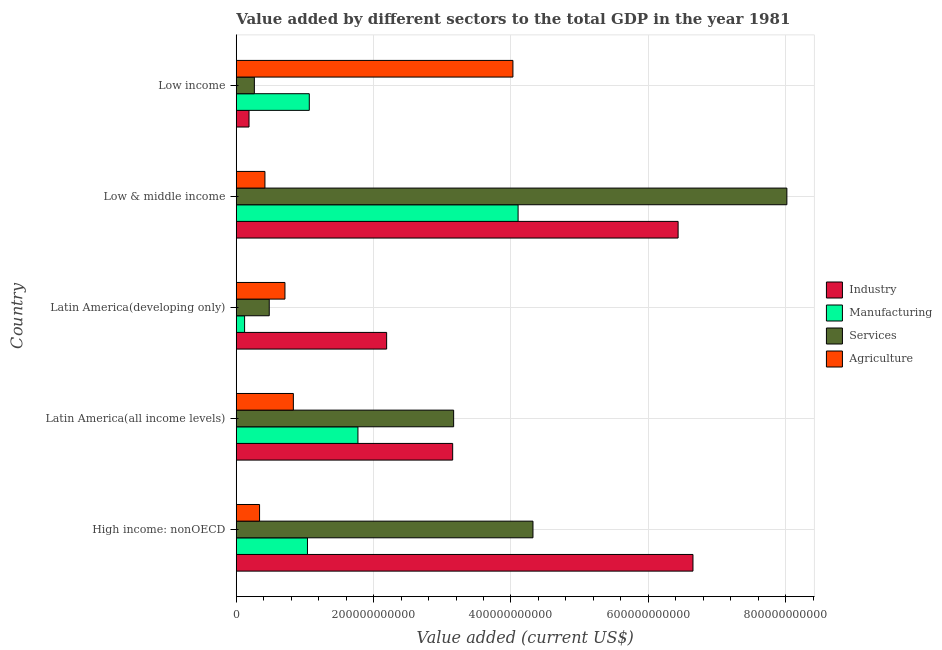How many groups of bars are there?
Provide a succinct answer. 5. Are the number of bars per tick equal to the number of legend labels?
Ensure brevity in your answer.  Yes. Are the number of bars on each tick of the Y-axis equal?
Offer a very short reply. Yes. How many bars are there on the 3rd tick from the top?
Provide a short and direct response. 4. What is the label of the 3rd group of bars from the top?
Make the answer very short. Latin America(developing only). In how many cases, is the number of bars for a given country not equal to the number of legend labels?
Offer a terse response. 0. What is the value added by agricultural sector in Latin America(developing only)?
Make the answer very short. 7.09e+1. Across all countries, what is the maximum value added by agricultural sector?
Keep it short and to the point. 4.03e+11. Across all countries, what is the minimum value added by agricultural sector?
Make the answer very short. 3.39e+1. What is the total value added by agricultural sector in the graph?
Ensure brevity in your answer.  6.33e+11. What is the difference between the value added by manufacturing sector in High income: nonOECD and that in Low income?
Your answer should be very brief. -2.65e+09. What is the difference between the value added by manufacturing sector in Low & middle income and the value added by industrial sector in Low income?
Offer a very short reply. 3.92e+11. What is the average value added by services sector per country?
Your response must be concise. 3.25e+11. What is the difference between the value added by agricultural sector and value added by manufacturing sector in Low & middle income?
Offer a very short reply. -3.69e+11. What is the ratio of the value added by services sector in High income: nonOECD to that in Low income?
Give a very brief answer. 16.39. Is the value added by industrial sector in Low & middle income less than that in Low income?
Offer a terse response. No. Is the difference between the value added by services sector in Latin America(all income levels) and Low & middle income greater than the difference between the value added by industrial sector in Latin America(all income levels) and Low & middle income?
Provide a short and direct response. No. What is the difference between the highest and the second highest value added by agricultural sector?
Make the answer very short. 3.20e+11. What is the difference between the highest and the lowest value added by industrial sector?
Provide a short and direct response. 6.46e+11. What does the 2nd bar from the top in Low & middle income represents?
Your response must be concise. Services. What does the 3rd bar from the bottom in High income: nonOECD represents?
Provide a short and direct response. Services. How many bars are there?
Ensure brevity in your answer.  20. Are all the bars in the graph horizontal?
Make the answer very short. Yes. What is the difference between two consecutive major ticks on the X-axis?
Make the answer very short. 2.00e+11. Are the values on the major ticks of X-axis written in scientific E-notation?
Provide a succinct answer. No. How many legend labels are there?
Your answer should be very brief. 4. How are the legend labels stacked?
Keep it short and to the point. Vertical. What is the title of the graph?
Provide a succinct answer. Value added by different sectors to the total GDP in the year 1981. Does "UNAIDS" appear as one of the legend labels in the graph?
Your answer should be very brief. No. What is the label or title of the X-axis?
Your response must be concise. Value added (current US$). What is the Value added (current US$) of Industry in High income: nonOECD?
Your response must be concise. 6.65e+11. What is the Value added (current US$) of Manufacturing in High income: nonOECD?
Offer a terse response. 1.04e+11. What is the Value added (current US$) of Services in High income: nonOECD?
Give a very brief answer. 4.32e+11. What is the Value added (current US$) of Agriculture in High income: nonOECD?
Provide a succinct answer. 3.39e+1. What is the Value added (current US$) in Industry in Latin America(all income levels)?
Provide a short and direct response. 3.15e+11. What is the Value added (current US$) of Manufacturing in Latin America(all income levels)?
Ensure brevity in your answer.  1.77e+11. What is the Value added (current US$) of Services in Latin America(all income levels)?
Keep it short and to the point. 3.17e+11. What is the Value added (current US$) in Agriculture in Latin America(all income levels)?
Offer a terse response. 8.31e+1. What is the Value added (current US$) in Industry in Latin America(developing only)?
Give a very brief answer. 2.19e+11. What is the Value added (current US$) of Manufacturing in Latin America(developing only)?
Keep it short and to the point. 1.21e+1. What is the Value added (current US$) in Services in Latin America(developing only)?
Offer a terse response. 4.80e+1. What is the Value added (current US$) of Agriculture in Latin America(developing only)?
Your answer should be compact. 7.09e+1. What is the Value added (current US$) in Industry in Low & middle income?
Provide a succinct answer. 6.43e+11. What is the Value added (current US$) of Manufacturing in Low & middle income?
Your answer should be compact. 4.10e+11. What is the Value added (current US$) in Services in Low & middle income?
Ensure brevity in your answer.  8.02e+11. What is the Value added (current US$) of Agriculture in Low & middle income?
Make the answer very short. 4.18e+1. What is the Value added (current US$) in Industry in Low income?
Provide a short and direct response. 1.86e+1. What is the Value added (current US$) in Manufacturing in Low income?
Give a very brief answer. 1.06e+11. What is the Value added (current US$) of Services in Low income?
Make the answer very short. 2.64e+1. What is the Value added (current US$) in Agriculture in Low income?
Ensure brevity in your answer.  4.03e+11. Across all countries, what is the maximum Value added (current US$) in Industry?
Provide a short and direct response. 6.65e+11. Across all countries, what is the maximum Value added (current US$) in Manufacturing?
Your answer should be very brief. 4.10e+11. Across all countries, what is the maximum Value added (current US$) in Services?
Give a very brief answer. 8.02e+11. Across all countries, what is the maximum Value added (current US$) in Agriculture?
Give a very brief answer. 4.03e+11. Across all countries, what is the minimum Value added (current US$) of Industry?
Provide a short and direct response. 1.86e+1. Across all countries, what is the minimum Value added (current US$) in Manufacturing?
Ensure brevity in your answer.  1.21e+1. Across all countries, what is the minimum Value added (current US$) in Services?
Keep it short and to the point. 2.64e+1. Across all countries, what is the minimum Value added (current US$) in Agriculture?
Provide a succinct answer. 3.39e+1. What is the total Value added (current US$) in Industry in the graph?
Provide a succinct answer. 1.86e+12. What is the total Value added (current US$) of Manufacturing in the graph?
Keep it short and to the point. 8.10e+11. What is the total Value added (current US$) of Services in the graph?
Make the answer very short. 1.62e+12. What is the total Value added (current US$) of Agriculture in the graph?
Give a very brief answer. 6.33e+11. What is the difference between the Value added (current US$) in Industry in High income: nonOECD and that in Latin America(all income levels)?
Your response must be concise. 3.50e+11. What is the difference between the Value added (current US$) in Manufacturing in High income: nonOECD and that in Latin America(all income levels)?
Keep it short and to the point. -7.35e+1. What is the difference between the Value added (current US$) of Services in High income: nonOECD and that in Latin America(all income levels)?
Give a very brief answer. 1.16e+11. What is the difference between the Value added (current US$) in Agriculture in High income: nonOECD and that in Latin America(all income levels)?
Ensure brevity in your answer.  -4.92e+1. What is the difference between the Value added (current US$) of Industry in High income: nonOECD and that in Latin America(developing only)?
Give a very brief answer. 4.46e+11. What is the difference between the Value added (current US$) of Manufacturing in High income: nonOECD and that in Latin America(developing only)?
Provide a succinct answer. 9.16e+1. What is the difference between the Value added (current US$) of Services in High income: nonOECD and that in Latin America(developing only)?
Offer a terse response. 3.84e+11. What is the difference between the Value added (current US$) in Agriculture in High income: nonOECD and that in Latin America(developing only)?
Offer a very short reply. -3.70e+1. What is the difference between the Value added (current US$) of Industry in High income: nonOECD and that in Low & middle income?
Offer a terse response. 2.16e+1. What is the difference between the Value added (current US$) in Manufacturing in High income: nonOECD and that in Low & middle income?
Provide a short and direct response. -3.07e+11. What is the difference between the Value added (current US$) of Services in High income: nonOECD and that in Low & middle income?
Your response must be concise. -3.70e+11. What is the difference between the Value added (current US$) of Agriculture in High income: nonOECD and that in Low & middle income?
Your answer should be compact. -7.83e+09. What is the difference between the Value added (current US$) in Industry in High income: nonOECD and that in Low income?
Your answer should be compact. 6.46e+11. What is the difference between the Value added (current US$) of Manufacturing in High income: nonOECD and that in Low income?
Your response must be concise. -2.65e+09. What is the difference between the Value added (current US$) of Services in High income: nonOECD and that in Low income?
Keep it short and to the point. 4.06e+11. What is the difference between the Value added (current US$) of Agriculture in High income: nonOECD and that in Low income?
Offer a terse response. -3.69e+11. What is the difference between the Value added (current US$) in Industry in Latin America(all income levels) and that in Latin America(developing only)?
Provide a short and direct response. 9.62e+1. What is the difference between the Value added (current US$) in Manufacturing in Latin America(all income levels) and that in Latin America(developing only)?
Ensure brevity in your answer.  1.65e+11. What is the difference between the Value added (current US$) of Services in Latin America(all income levels) and that in Latin America(developing only)?
Offer a terse response. 2.68e+11. What is the difference between the Value added (current US$) in Agriculture in Latin America(all income levels) and that in Latin America(developing only)?
Your answer should be very brief. 1.22e+1. What is the difference between the Value added (current US$) in Industry in Latin America(all income levels) and that in Low & middle income?
Ensure brevity in your answer.  -3.28e+11. What is the difference between the Value added (current US$) in Manufacturing in Latin America(all income levels) and that in Low & middle income?
Provide a succinct answer. -2.33e+11. What is the difference between the Value added (current US$) in Services in Latin America(all income levels) and that in Low & middle income?
Give a very brief answer. -4.85e+11. What is the difference between the Value added (current US$) in Agriculture in Latin America(all income levels) and that in Low & middle income?
Keep it short and to the point. 4.14e+1. What is the difference between the Value added (current US$) in Industry in Latin America(all income levels) and that in Low income?
Your answer should be very brief. 2.97e+11. What is the difference between the Value added (current US$) of Manufacturing in Latin America(all income levels) and that in Low income?
Your response must be concise. 7.08e+1. What is the difference between the Value added (current US$) in Services in Latin America(all income levels) and that in Low income?
Make the answer very short. 2.90e+11. What is the difference between the Value added (current US$) in Agriculture in Latin America(all income levels) and that in Low income?
Your answer should be very brief. -3.20e+11. What is the difference between the Value added (current US$) in Industry in Latin America(developing only) and that in Low & middle income?
Ensure brevity in your answer.  -4.24e+11. What is the difference between the Value added (current US$) of Manufacturing in Latin America(developing only) and that in Low & middle income?
Your answer should be very brief. -3.98e+11. What is the difference between the Value added (current US$) in Services in Latin America(developing only) and that in Low & middle income?
Give a very brief answer. -7.54e+11. What is the difference between the Value added (current US$) of Agriculture in Latin America(developing only) and that in Low & middle income?
Make the answer very short. 2.91e+1. What is the difference between the Value added (current US$) in Industry in Latin America(developing only) and that in Low income?
Offer a very short reply. 2.00e+11. What is the difference between the Value added (current US$) in Manufacturing in Latin America(developing only) and that in Low income?
Keep it short and to the point. -9.42e+1. What is the difference between the Value added (current US$) of Services in Latin America(developing only) and that in Low income?
Provide a succinct answer. 2.17e+1. What is the difference between the Value added (current US$) in Agriculture in Latin America(developing only) and that in Low income?
Your answer should be compact. -3.32e+11. What is the difference between the Value added (current US$) of Industry in Low & middle income and that in Low income?
Provide a succinct answer. 6.25e+11. What is the difference between the Value added (current US$) of Manufacturing in Low & middle income and that in Low income?
Offer a terse response. 3.04e+11. What is the difference between the Value added (current US$) of Services in Low & middle income and that in Low income?
Give a very brief answer. 7.75e+11. What is the difference between the Value added (current US$) of Agriculture in Low & middle income and that in Low income?
Your response must be concise. -3.61e+11. What is the difference between the Value added (current US$) of Industry in High income: nonOECD and the Value added (current US$) of Manufacturing in Latin America(all income levels)?
Offer a terse response. 4.88e+11. What is the difference between the Value added (current US$) of Industry in High income: nonOECD and the Value added (current US$) of Services in Latin America(all income levels)?
Ensure brevity in your answer.  3.48e+11. What is the difference between the Value added (current US$) of Industry in High income: nonOECD and the Value added (current US$) of Agriculture in Latin America(all income levels)?
Provide a short and direct response. 5.82e+11. What is the difference between the Value added (current US$) of Manufacturing in High income: nonOECD and the Value added (current US$) of Services in Latin America(all income levels)?
Give a very brief answer. -2.13e+11. What is the difference between the Value added (current US$) in Manufacturing in High income: nonOECD and the Value added (current US$) in Agriculture in Latin America(all income levels)?
Your answer should be very brief. 2.05e+1. What is the difference between the Value added (current US$) in Services in High income: nonOECD and the Value added (current US$) in Agriculture in Latin America(all income levels)?
Your answer should be compact. 3.49e+11. What is the difference between the Value added (current US$) of Industry in High income: nonOECD and the Value added (current US$) of Manufacturing in Latin America(developing only)?
Keep it short and to the point. 6.53e+11. What is the difference between the Value added (current US$) in Industry in High income: nonOECD and the Value added (current US$) in Services in Latin America(developing only)?
Your response must be concise. 6.17e+11. What is the difference between the Value added (current US$) in Industry in High income: nonOECD and the Value added (current US$) in Agriculture in Latin America(developing only)?
Ensure brevity in your answer.  5.94e+11. What is the difference between the Value added (current US$) of Manufacturing in High income: nonOECD and the Value added (current US$) of Services in Latin America(developing only)?
Your answer should be very brief. 5.57e+1. What is the difference between the Value added (current US$) in Manufacturing in High income: nonOECD and the Value added (current US$) in Agriculture in Latin America(developing only)?
Offer a terse response. 3.28e+1. What is the difference between the Value added (current US$) in Services in High income: nonOECD and the Value added (current US$) in Agriculture in Latin America(developing only)?
Offer a terse response. 3.61e+11. What is the difference between the Value added (current US$) in Industry in High income: nonOECD and the Value added (current US$) in Manufacturing in Low & middle income?
Offer a terse response. 2.55e+11. What is the difference between the Value added (current US$) in Industry in High income: nonOECD and the Value added (current US$) in Services in Low & middle income?
Provide a short and direct response. -1.37e+11. What is the difference between the Value added (current US$) of Industry in High income: nonOECD and the Value added (current US$) of Agriculture in Low & middle income?
Your answer should be very brief. 6.23e+11. What is the difference between the Value added (current US$) of Manufacturing in High income: nonOECD and the Value added (current US$) of Services in Low & middle income?
Give a very brief answer. -6.98e+11. What is the difference between the Value added (current US$) of Manufacturing in High income: nonOECD and the Value added (current US$) of Agriculture in Low & middle income?
Provide a succinct answer. 6.19e+1. What is the difference between the Value added (current US$) in Services in High income: nonOECD and the Value added (current US$) in Agriculture in Low & middle income?
Ensure brevity in your answer.  3.90e+11. What is the difference between the Value added (current US$) of Industry in High income: nonOECD and the Value added (current US$) of Manufacturing in Low income?
Your answer should be compact. 5.59e+11. What is the difference between the Value added (current US$) of Industry in High income: nonOECD and the Value added (current US$) of Services in Low income?
Give a very brief answer. 6.39e+11. What is the difference between the Value added (current US$) in Industry in High income: nonOECD and the Value added (current US$) in Agriculture in Low income?
Keep it short and to the point. 2.62e+11. What is the difference between the Value added (current US$) of Manufacturing in High income: nonOECD and the Value added (current US$) of Services in Low income?
Your response must be concise. 7.73e+1. What is the difference between the Value added (current US$) in Manufacturing in High income: nonOECD and the Value added (current US$) in Agriculture in Low income?
Give a very brief answer. -2.99e+11. What is the difference between the Value added (current US$) of Services in High income: nonOECD and the Value added (current US$) of Agriculture in Low income?
Your answer should be very brief. 2.92e+1. What is the difference between the Value added (current US$) of Industry in Latin America(all income levels) and the Value added (current US$) of Manufacturing in Latin America(developing only)?
Your answer should be very brief. 3.03e+11. What is the difference between the Value added (current US$) of Industry in Latin America(all income levels) and the Value added (current US$) of Services in Latin America(developing only)?
Provide a succinct answer. 2.67e+11. What is the difference between the Value added (current US$) in Industry in Latin America(all income levels) and the Value added (current US$) in Agriculture in Latin America(developing only)?
Offer a terse response. 2.44e+11. What is the difference between the Value added (current US$) in Manufacturing in Latin America(all income levels) and the Value added (current US$) in Services in Latin America(developing only)?
Offer a terse response. 1.29e+11. What is the difference between the Value added (current US$) of Manufacturing in Latin America(all income levels) and the Value added (current US$) of Agriculture in Latin America(developing only)?
Ensure brevity in your answer.  1.06e+11. What is the difference between the Value added (current US$) in Services in Latin America(all income levels) and the Value added (current US$) in Agriculture in Latin America(developing only)?
Keep it short and to the point. 2.46e+11. What is the difference between the Value added (current US$) of Industry in Latin America(all income levels) and the Value added (current US$) of Manufacturing in Low & middle income?
Your response must be concise. -9.53e+1. What is the difference between the Value added (current US$) of Industry in Latin America(all income levels) and the Value added (current US$) of Services in Low & middle income?
Make the answer very short. -4.87e+11. What is the difference between the Value added (current US$) in Industry in Latin America(all income levels) and the Value added (current US$) in Agriculture in Low & middle income?
Give a very brief answer. 2.73e+11. What is the difference between the Value added (current US$) in Manufacturing in Latin America(all income levels) and the Value added (current US$) in Services in Low & middle income?
Ensure brevity in your answer.  -6.25e+11. What is the difference between the Value added (current US$) of Manufacturing in Latin America(all income levels) and the Value added (current US$) of Agriculture in Low & middle income?
Give a very brief answer. 1.35e+11. What is the difference between the Value added (current US$) of Services in Latin America(all income levels) and the Value added (current US$) of Agriculture in Low & middle income?
Offer a terse response. 2.75e+11. What is the difference between the Value added (current US$) in Industry in Latin America(all income levels) and the Value added (current US$) in Manufacturing in Low income?
Ensure brevity in your answer.  2.09e+11. What is the difference between the Value added (current US$) in Industry in Latin America(all income levels) and the Value added (current US$) in Services in Low income?
Provide a succinct answer. 2.89e+11. What is the difference between the Value added (current US$) of Industry in Latin America(all income levels) and the Value added (current US$) of Agriculture in Low income?
Make the answer very short. -8.77e+1. What is the difference between the Value added (current US$) in Manufacturing in Latin America(all income levels) and the Value added (current US$) in Services in Low income?
Your answer should be very brief. 1.51e+11. What is the difference between the Value added (current US$) of Manufacturing in Latin America(all income levels) and the Value added (current US$) of Agriculture in Low income?
Offer a terse response. -2.26e+11. What is the difference between the Value added (current US$) in Services in Latin America(all income levels) and the Value added (current US$) in Agriculture in Low income?
Your response must be concise. -8.63e+1. What is the difference between the Value added (current US$) in Industry in Latin America(developing only) and the Value added (current US$) in Manufacturing in Low & middle income?
Provide a short and direct response. -1.91e+11. What is the difference between the Value added (current US$) of Industry in Latin America(developing only) and the Value added (current US$) of Services in Low & middle income?
Ensure brevity in your answer.  -5.83e+11. What is the difference between the Value added (current US$) in Industry in Latin America(developing only) and the Value added (current US$) in Agriculture in Low & middle income?
Make the answer very short. 1.77e+11. What is the difference between the Value added (current US$) in Manufacturing in Latin America(developing only) and the Value added (current US$) in Services in Low & middle income?
Offer a terse response. -7.90e+11. What is the difference between the Value added (current US$) of Manufacturing in Latin America(developing only) and the Value added (current US$) of Agriculture in Low & middle income?
Make the answer very short. -2.96e+1. What is the difference between the Value added (current US$) of Services in Latin America(developing only) and the Value added (current US$) of Agriculture in Low & middle income?
Offer a very short reply. 6.27e+09. What is the difference between the Value added (current US$) in Industry in Latin America(developing only) and the Value added (current US$) in Manufacturing in Low income?
Your response must be concise. 1.13e+11. What is the difference between the Value added (current US$) of Industry in Latin America(developing only) and the Value added (current US$) of Services in Low income?
Your answer should be very brief. 1.93e+11. What is the difference between the Value added (current US$) of Industry in Latin America(developing only) and the Value added (current US$) of Agriculture in Low income?
Give a very brief answer. -1.84e+11. What is the difference between the Value added (current US$) of Manufacturing in Latin America(developing only) and the Value added (current US$) of Services in Low income?
Your answer should be compact. -1.42e+1. What is the difference between the Value added (current US$) of Manufacturing in Latin America(developing only) and the Value added (current US$) of Agriculture in Low income?
Give a very brief answer. -3.91e+11. What is the difference between the Value added (current US$) of Services in Latin America(developing only) and the Value added (current US$) of Agriculture in Low income?
Ensure brevity in your answer.  -3.55e+11. What is the difference between the Value added (current US$) in Industry in Low & middle income and the Value added (current US$) in Manufacturing in Low income?
Offer a terse response. 5.37e+11. What is the difference between the Value added (current US$) of Industry in Low & middle income and the Value added (current US$) of Services in Low income?
Keep it short and to the point. 6.17e+11. What is the difference between the Value added (current US$) of Industry in Low & middle income and the Value added (current US$) of Agriculture in Low income?
Offer a terse response. 2.41e+11. What is the difference between the Value added (current US$) of Manufacturing in Low & middle income and the Value added (current US$) of Services in Low income?
Give a very brief answer. 3.84e+11. What is the difference between the Value added (current US$) in Manufacturing in Low & middle income and the Value added (current US$) in Agriculture in Low income?
Ensure brevity in your answer.  7.53e+09. What is the difference between the Value added (current US$) in Services in Low & middle income and the Value added (current US$) in Agriculture in Low income?
Provide a short and direct response. 3.99e+11. What is the average Value added (current US$) of Industry per country?
Provide a short and direct response. 3.72e+11. What is the average Value added (current US$) in Manufacturing per country?
Ensure brevity in your answer.  1.62e+11. What is the average Value added (current US$) of Services per country?
Offer a very short reply. 3.25e+11. What is the average Value added (current US$) of Agriculture per country?
Your answer should be compact. 1.27e+11. What is the difference between the Value added (current US$) in Industry and Value added (current US$) in Manufacturing in High income: nonOECD?
Your answer should be compact. 5.61e+11. What is the difference between the Value added (current US$) of Industry and Value added (current US$) of Services in High income: nonOECD?
Give a very brief answer. 2.33e+11. What is the difference between the Value added (current US$) in Industry and Value added (current US$) in Agriculture in High income: nonOECD?
Your answer should be compact. 6.31e+11. What is the difference between the Value added (current US$) of Manufacturing and Value added (current US$) of Services in High income: nonOECD?
Offer a terse response. -3.28e+11. What is the difference between the Value added (current US$) in Manufacturing and Value added (current US$) in Agriculture in High income: nonOECD?
Provide a short and direct response. 6.98e+1. What is the difference between the Value added (current US$) of Services and Value added (current US$) of Agriculture in High income: nonOECD?
Your answer should be very brief. 3.98e+11. What is the difference between the Value added (current US$) in Industry and Value added (current US$) in Manufacturing in Latin America(all income levels)?
Ensure brevity in your answer.  1.38e+11. What is the difference between the Value added (current US$) of Industry and Value added (current US$) of Services in Latin America(all income levels)?
Provide a succinct answer. -1.41e+09. What is the difference between the Value added (current US$) in Industry and Value added (current US$) in Agriculture in Latin America(all income levels)?
Your response must be concise. 2.32e+11. What is the difference between the Value added (current US$) in Manufacturing and Value added (current US$) in Services in Latin America(all income levels)?
Your answer should be compact. -1.39e+11. What is the difference between the Value added (current US$) of Manufacturing and Value added (current US$) of Agriculture in Latin America(all income levels)?
Your response must be concise. 9.40e+1. What is the difference between the Value added (current US$) in Services and Value added (current US$) in Agriculture in Latin America(all income levels)?
Your response must be concise. 2.33e+11. What is the difference between the Value added (current US$) in Industry and Value added (current US$) in Manufacturing in Latin America(developing only)?
Give a very brief answer. 2.07e+11. What is the difference between the Value added (current US$) of Industry and Value added (current US$) of Services in Latin America(developing only)?
Keep it short and to the point. 1.71e+11. What is the difference between the Value added (current US$) of Industry and Value added (current US$) of Agriculture in Latin America(developing only)?
Keep it short and to the point. 1.48e+11. What is the difference between the Value added (current US$) of Manufacturing and Value added (current US$) of Services in Latin America(developing only)?
Your answer should be very brief. -3.59e+1. What is the difference between the Value added (current US$) in Manufacturing and Value added (current US$) in Agriculture in Latin America(developing only)?
Keep it short and to the point. -5.88e+1. What is the difference between the Value added (current US$) in Services and Value added (current US$) in Agriculture in Latin America(developing only)?
Ensure brevity in your answer.  -2.29e+1. What is the difference between the Value added (current US$) in Industry and Value added (current US$) in Manufacturing in Low & middle income?
Your response must be concise. 2.33e+11. What is the difference between the Value added (current US$) in Industry and Value added (current US$) in Services in Low & middle income?
Offer a terse response. -1.58e+11. What is the difference between the Value added (current US$) of Industry and Value added (current US$) of Agriculture in Low & middle income?
Ensure brevity in your answer.  6.02e+11. What is the difference between the Value added (current US$) of Manufacturing and Value added (current US$) of Services in Low & middle income?
Your answer should be compact. -3.91e+11. What is the difference between the Value added (current US$) in Manufacturing and Value added (current US$) in Agriculture in Low & middle income?
Ensure brevity in your answer.  3.69e+11. What is the difference between the Value added (current US$) in Services and Value added (current US$) in Agriculture in Low & middle income?
Give a very brief answer. 7.60e+11. What is the difference between the Value added (current US$) in Industry and Value added (current US$) in Manufacturing in Low income?
Ensure brevity in your answer.  -8.78e+1. What is the difference between the Value added (current US$) in Industry and Value added (current US$) in Services in Low income?
Ensure brevity in your answer.  -7.77e+09. What is the difference between the Value added (current US$) in Industry and Value added (current US$) in Agriculture in Low income?
Ensure brevity in your answer.  -3.84e+11. What is the difference between the Value added (current US$) in Manufacturing and Value added (current US$) in Services in Low income?
Keep it short and to the point. 8.00e+1. What is the difference between the Value added (current US$) in Manufacturing and Value added (current US$) in Agriculture in Low income?
Offer a very short reply. -2.96e+11. What is the difference between the Value added (current US$) of Services and Value added (current US$) of Agriculture in Low income?
Keep it short and to the point. -3.76e+11. What is the ratio of the Value added (current US$) in Industry in High income: nonOECD to that in Latin America(all income levels)?
Provide a succinct answer. 2.11. What is the ratio of the Value added (current US$) in Manufacturing in High income: nonOECD to that in Latin America(all income levels)?
Offer a terse response. 0.59. What is the ratio of the Value added (current US$) of Services in High income: nonOECD to that in Latin America(all income levels)?
Your answer should be compact. 1.36. What is the ratio of the Value added (current US$) in Agriculture in High income: nonOECD to that in Latin America(all income levels)?
Your answer should be very brief. 0.41. What is the ratio of the Value added (current US$) in Industry in High income: nonOECD to that in Latin America(developing only)?
Provide a short and direct response. 3.04. What is the ratio of the Value added (current US$) of Manufacturing in High income: nonOECD to that in Latin America(developing only)?
Your response must be concise. 8.54. What is the ratio of the Value added (current US$) in Services in High income: nonOECD to that in Latin America(developing only)?
Make the answer very short. 8.99. What is the ratio of the Value added (current US$) of Agriculture in High income: nonOECD to that in Latin America(developing only)?
Offer a very short reply. 0.48. What is the ratio of the Value added (current US$) in Industry in High income: nonOECD to that in Low & middle income?
Your answer should be very brief. 1.03. What is the ratio of the Value added (current US$) in Manufacturing in High income: nonOECD to that in Low & middle income?
Provide a succinct answer. 0.25. What is the ratio of the Value added (current US$) of Services in High income: nonOECD to that in Low & middle income?
Provide a succinct answer. 0.54. What is the ratio of the Value added (current US$) in Agriculture in High income: nonOECD to that in Low & middle income?
Make the answer very short. 0.81. What is the ratio of the Value added (current US$) in Industry in High income: nonOECD to that in Low income?
Keep it short and to the point. 35.78. What is the ratio of the Value added (current US$) in Manufacturing in High income: nonOECD to that in Low income?
Ensure brevity in your answer.  0.98. What is the ratio of the Value added (current US$) of Services in High income: nonOECD to that in Low income?
Your answer should be compact. 16.39. What is the ratio of the Value added (current US$) of Agriculture in High income: nonOECD to that in Low income?
Give a very brief answer. 0.08. What is the ratio of the Value added (current US$) of Industry in Latin America(all income levels) to that in Latin America(developing only)?
Provide a succinct answer. 1.44. What is the ratio of the Value added (current US$) of Manufacturing in Latin America(all income levels) to that in Latin America(developing only)?
Ensure brevity in your answer.  14.6. What is the ratio of the Value added (current US$) of Services in Latin America(all income levels) to that in Latin America(developing only)?
Ensure brevity in your answer.  6.59. What is the ratio of the Value added (current US$) in Agriculture in Latin America(all income levels) to that in Latin America(developing only)?
Provide a succinct answer. 1.17. What is the ratio of the Value added (current US$) in Industry in Latin America(all income levels) to that in Low & middle income?
Provide a succinct answer. 0.49. What is the ratio of the Value added (current US$) in Manufacturing in Latin America(all income levels) to that in Low & middle income?
Your response must be concise. 0.43. What is the ratio of the Value added (current US$) in Services in Latin America(all income levels) to that in Low & middle income?
Ensure brevity in your answer.  0.39. What is the ratio of the Value added (current US$) in Agriculture in Latin America(all income levels) to that in Low & middle income?
Give a very brief answer. 1.99. What is the ratio of the Value added (current US$) in Industry in Latin America(all income levels) to that in Low income?
Ensure brevity in your answer.  16.96. What is the ratio of the Value added (current US$) in Manufacturing in Latin America(all income levels) to that in Low income?
Make the answer very short. 1.67. What is the ratio of the Value added (current US$) of Services in Latin America(all income levels) to that in Low income?
Your answer should be compact. 12.01. What is the ratio of the Value added (current US$) of Agriculture in Latin America(all income levels) to that in Low income?
Make the answer very short. 0.21. What is the ratio of the Value added (current US$) of Industry in Latin America(developing only) to that in Low & middle income?
Ensure brevity in your answer.  0.34. What is the ratio of the Value added (current US$) in Manufacturing in Latin America(developing only) to that in Low & middle income?
Your answer should be compact. 0.03. What is the ratio of the Value added (current US$) in Services in Latin America(developing only) to that in Low & middle income?
Your answer should be compact. 0.06. What is the ratio of the Value added (current US$) of Agriculture in Latin America(developing only) to that in Low & middle income?
Offer a terse response. 1.7. What is the ratio of the Value added (current US$) in Industry in Latin America(developing only) to that in Low income?
Offer a very short reply. 11.78. What is the ratio of the Value added (current US$) in Manufacturing in Latin America(developing only) to that in Low income?
Make the answer very short. 0.11. What is the ratio of the Value added (current US$) in Services in Latin America(developing only) to that in Low income?
Offer a very short reply. 1.82. What is the ratio of the Value added (current US$) of Agriculture in Latin America(developing only) to that in Low income?
Your response must be concise. 0.18. What is the ratio of the Value added (current US$) of Industry in Low & middle income to that in Low income?
Ensure brevity in your answer.  34.62. What is the ratio of the Value added (current US$) of Manufacturing in Low & middle income to that in Low income?
Your answer should be very brief. 3.86. What is the ratio of the Value added (current US$) in Services in Low & middle income to that in Low income?
Provide a succinct answer. 30.42. What is the ratio of the Value added (current US$) in Agriculture in Low & middle income to that in Low income?
Offer a terse response. 0.1. What is the difference between the highest and the second highest Value added (current US$) of Industry?
Ensure brevity in your answer.  2.16e+1. What is the difference between the highest and the second highest Value added (current US$) in Manufacturing?
Your answer should be compact. 2.33e+11. What is the difference between the highest and the second highest Value added (current US$) of Services?
Ensure brevity in your answer.  3.70e+11. What is the difference between the highest and the second highest Value added (current US$) of Agriculture?
Provide a succinct answer. 3.20e+11. What is the difference between the highest and the lowest Value added (current US$) in Industry?
Ensure brevity in your answer.  6.46e+11. What is the difference between the highest and the lowest Value added (current US$) in Manufacturing?
Your answer should be compact. 3.98e+11. What is the difference between the highest and the lowest Value added (current US$) of Services?
Keep it short and to the point. 7.75e+11. What is the difference between the highest and the lowest Value added (current US$) in Agriculture?
Your answer should be compact. 3.69e+11. 